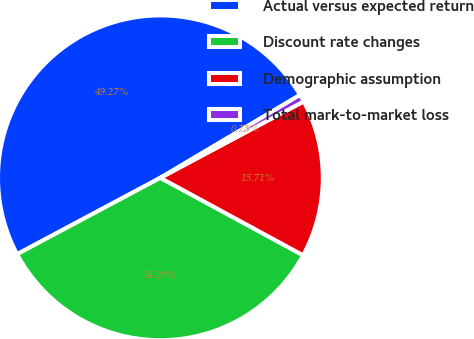Convert chart. <chart><loc_0><loc_0><loc_500><loc_500><pie_chart><fcel>Actual versus expected return<fcel>Discount rate changes<fcel>Demographic assumption<fcel>Total mark-to-market loss<nl><fcel>49.27%<fcel>34.29%<fcel>15.71%<fcel>0.73%<nl></chart> 